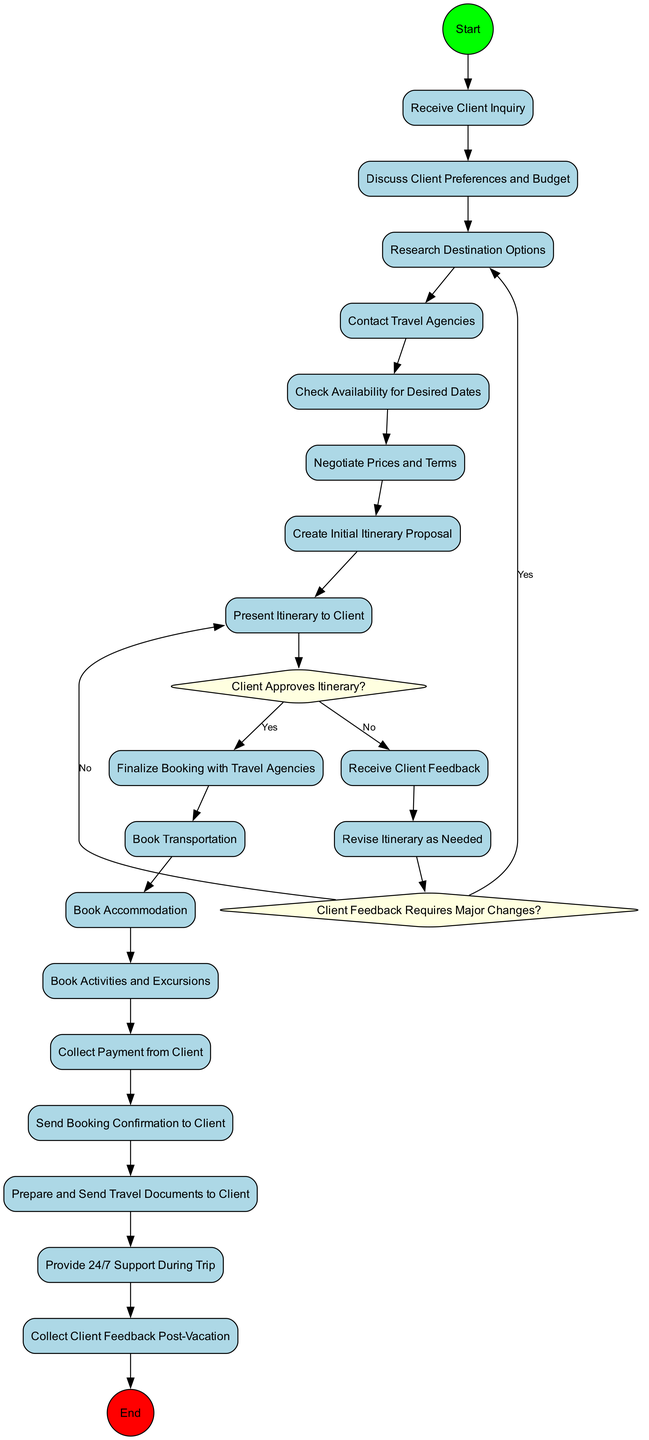What is the starting point of the activity diagram? The starting point is represented by the "Receive Client Inquiry" node, which is the first activity that initiates the workflow in the diagram.
Answer: Receive Client Inquiry How many total activities are listed in the diagram? There are 17 activities outlined in the diagram, which include actions such as discussing preferences and booking accommodations.
Answer: 17 What decision follows "Present Itinerary to Client"? After "Present Itinerary to Client," the decision point is "Client Approves Itinerary?" where the next steps depend on the client's approval.
Answer: Client Approves Itinerary? Which activity occurs after "Revise Itinerary as Needed"? The next activity after "Revise Itinerary as Needed" is determined by the decision "Client Feedback Requires Major Changes?" that leads to further actions based on the client's feedback.
Answer: Client Feedback Requires Major Changes? What happens if the client does not approve the itinerary? If the client does not approve the itinerary, the flow goes to "Receive Client Feedback," which initiates further revisions based on the client's input.
Answer: Receive Client Feedback How many decision nodes are present in the diagram? There are 2 decision nodes in the diagram, which are "Client Approves Itinerary?" and "Client Feedback Requires Major Changes?" used to direct the workflow based on client responses.
Answer: 2 What is the concluding action in the activity diagram? The concluding action in the diagram is "Collect Client Feedback Post-Vacation," which signifies the end of the client's vacation process.
Answer: Collect Client Feedback Post-Vacation What activity is performed just before "Send Booking Confirmation to Client"? The activity that occurs right before "Send Booking Confirmation to Client" is "Collect Payment from Client," ensuring that payment is received prior to confirming the booking.
Answer: Collect Payment from Client What is the final destination of the flow in the activity diagram? The final destination, or end node, of the flow in the diagram is marked as "Collect Client Feedback Post-Vacation," completing the travel arrangement process.
Answer: Collect Client Feedback Post-Vacation 